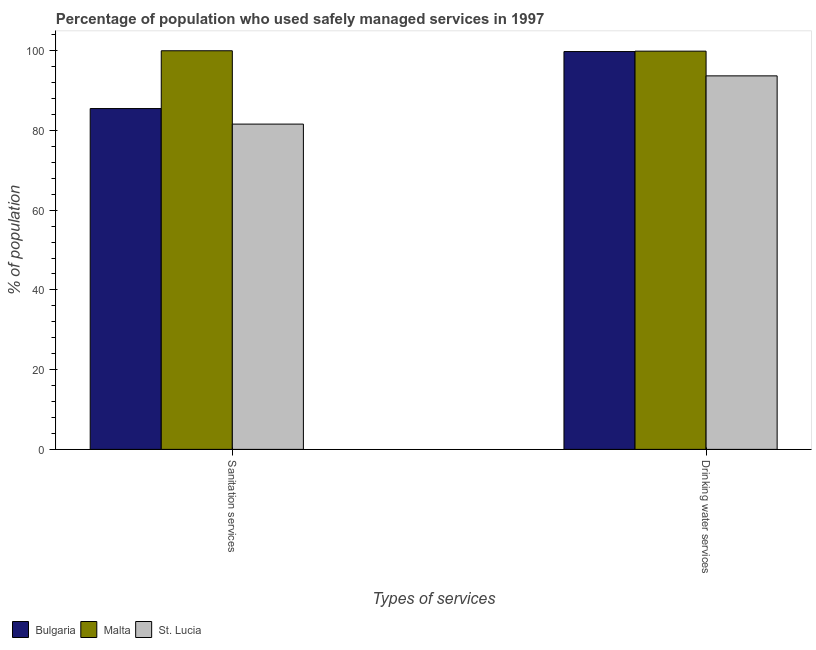How many different coloured bars are there?
Ensure brevity in your answer.  3. How many bars are there on the 1st tick from the left?
Provide a short and direct response. 3. How many bars are there on the 2nd tick from the right?
Offer a terse response. 3. What is the label of the 1st group of bars from the left?
Ensure brevity in your answer.  Sanitation services. What is the percentage of population who used sanitation services in Malta?
Ensure brevity in your answer.  100. Across all countries, what is the maximum percentage of population who used drinking water services?
Provide a succinct answer. 99.9. Across all countries, what is the minimum percentage of population who used drinking water services?
Give a very brief answer. 93.7. In which country was the percentage of population who used sanitation services maximum?
Give a very brief answer. Malta. In which country was the percentage of population who used drinking water services minimum?
Your response must be concise. St. Lucia. What is the total percentage of population who used sanitation services in the graph?
Offer a terse response. 267.1. What is the difference between the percentage of population who used drinking water services in Malta and that in St. Lucia?
Your answer should be compact. 6.2. What is the difference between the percentage of population who used drinking water services in St. Lucia and the percentage of population who used sanitation services in Malta?
Ensure brevity in your answer.  -6.3. What is the average percentage of population who used sanitation services per country?
Your answer should be compact. 89.03. What is the difference between the percentage of population who used sanitation services and percentage of population who used drinking water services in Bulgaria?
Ensure brevity in your answer.  -14.3. What is the ratio of the percentage of population who used sanitation services in Malta to that in St. Lucia?
Your answer should be compact. 1.23. Is the percentage of population who used drinking water services in St. Lucia less than that in Malta?
Offer a terse response. Yes. In how many countries, is the percentage of population who used drinking water services greater than the average percentage of population who used drinking water services taken over all countries?
Give a very brief answer. 2. What does the 2nd bar from the left in Sanitation services represents?
Make the answer very short. Malta. What does the 1st bar from the right in Sanitation services represents?
Make the answer very short. St. Lucia. Are all the bars in the graph horizontal?
Your response must be concise. No. Are the values on the major ticks of Y-axis written in scientific E-notation?
Ensure brevity in your answer.  No. Does the graph contain any zero values?
Offer a very short reply. No. What is the title of the graph?
Your answer should be compact. Percentage of population who used safely managed services in 1997. Does "Pacific island small states" appear as one of the legend labels in the graph?
Provide a short and direct response. No. What is the label or title of the X-axis?
Your answer should be very brief. Types of services. What is the label or title of the Y-axis?
Your response must be concise. % of population. What is the % of population of Bulgaria in Sanitation services?
Your answer should be compact. 85.5. What is the % of population in St. Lucia in Sanitation services?
Provide a short and direct response. 81.6. What is the % of population in Bulgaria in Drinking water services?
Your answer should be compact. 99.8. What is the % of population in Malta in Drinking water services?
Your answer should be very brief. 99.9. What is the % of population in St. Lucia in Drinking water services?
Your answer should be compact. 93.7. Across all Types of services, what is the maximum % of population in Bulgaria?
Provide a succinct answer. 99.8. Across all Types of services, what is the maximum % of population in St. Lucia?
Offer a terse response. 93.7. Across all Types of services, what is the minimum % of population in Bulgaria?
Ensure brevity in your answer.  85.5. Across all Types of services, what is the minimum % of population in Malta?
Provide a succinct answer. 99.9. Across all Types of services, what is the minimum % of population of St. Lucia?
Keep it short and to the point. 81.6. What is the total % of population in Bulgaria in the graph?
Offer a very short reply. 185.3. What is the total % of population of Malta in the graph?
Provide a short and direct response. 199.9. What is the total % of population of St. Lucia in the graph?
Ensure brevity in your answer.  175.3. What is the difference between the % of population in Bulgaria in Sanitation services and that in Drinking water services?
Offer a very short reply. -14.3. What is the difference between the % of population of Bulgaria in Sanitation services and the % of population of Malta in Drinking water services?
Your answer should be compact. -14.4. What is the difference between the % of population in Bulgaria in Sanitation services and the % of population in St. Lucia in Drinking water services?
Keep it short and to the point. -8.2. What is the difference between the % of population in Malta in Sanitation services and the % of population in St. Lucia in Drinking water services?
Offer a terse response. 6.3. What is the average % of population in Bulgaria per Types of services?
Offer a very short reply. 92.65. What is the average % of population of Malta per Types of services?
Keep it short and to the point. 99.95. What is the average % of population of St. Lucia per Types of services?
Provide a succinct answer. 87.65. What is the difference between the % of population in Bulgaria and % of population in Malta in Sanitation services?
Make the answer very short. -14.5. What is the difference between the % of population of Bulgaria and % of population of St. Lucia in Sanitation services?
Make the answer very short. 3.9. What is the difference between the % of population in Bulgaria and % of population in Malta in Drinking water services?
Ensure brevity in your answer.  -0.1. What is the difference between the % of population in Malta and % of population in St. Lucia in Drinking water services?
Your response must be concise. 6.2. What is the ratio of the % of population of Bulgaria in Sanitation services to that in Drinking water services?
Give a very brief answer. 0.86. What is the ratio of the % of population of Malta in Sanitation services to that in Drinking water services?
Provide a short and direct response. 1. What is the ratio of the % of population in St. Lucia in Sanitation services to that in Drinking water services?
Make the answer very short. 0.87. What is the difference between the highest and the second highest % of population of Malta?
Provide a short and direct response. 0.1. What is the difference between the highest and the second highest % of population in St. Lucia?
Offer a very short reply. 12.1. What is the difference between the highest and the lowest % of population of Bulgaria?
Give a very brief answer. 14.3. What is the difference between the highest and the lowest % of population in Malta?
Give a very brief answer. 0.1. What is the difference between the highest and the lowest % of population of St. Lucia?
Offer a very short reply. 12.1. 